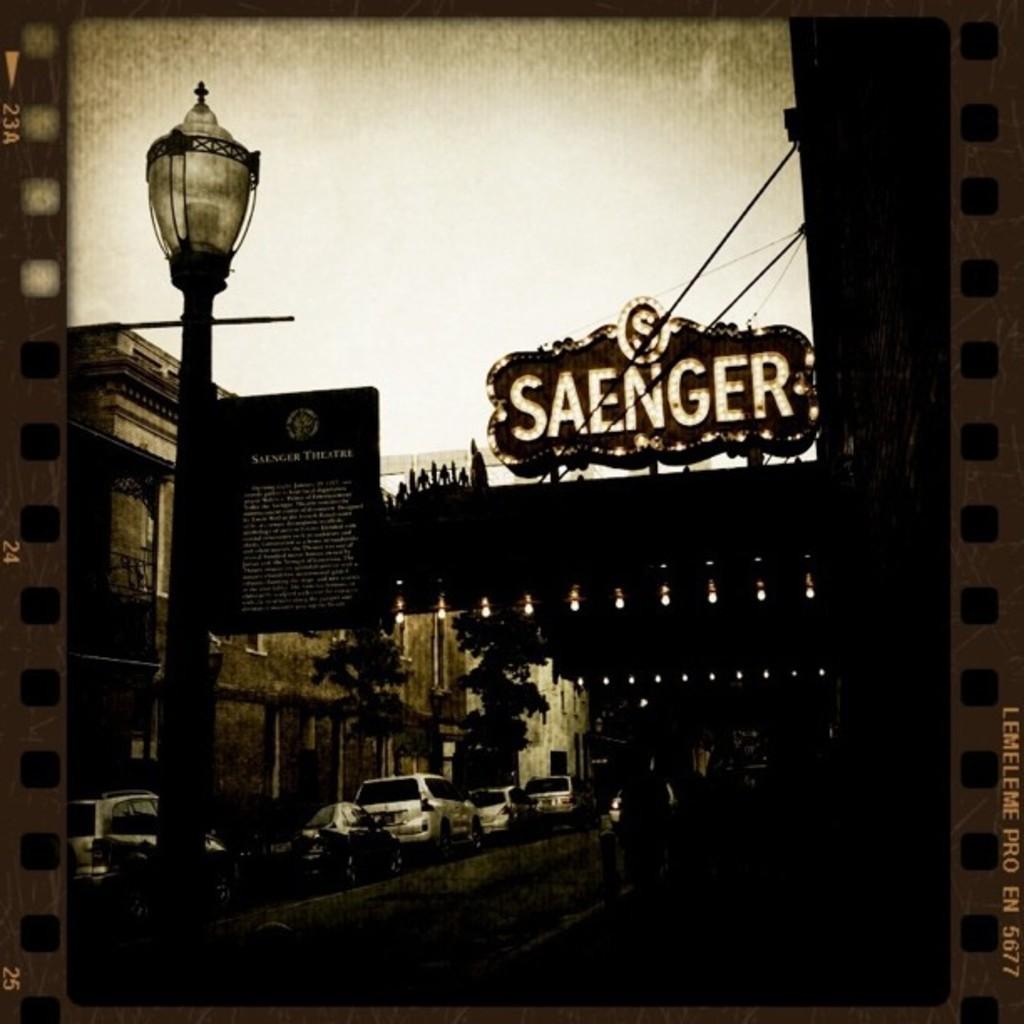Describe this image in one or two sentences. In this picture we can see few vehicles, buildings, trees, pole and lights, on the right side of the image we can see some text. 